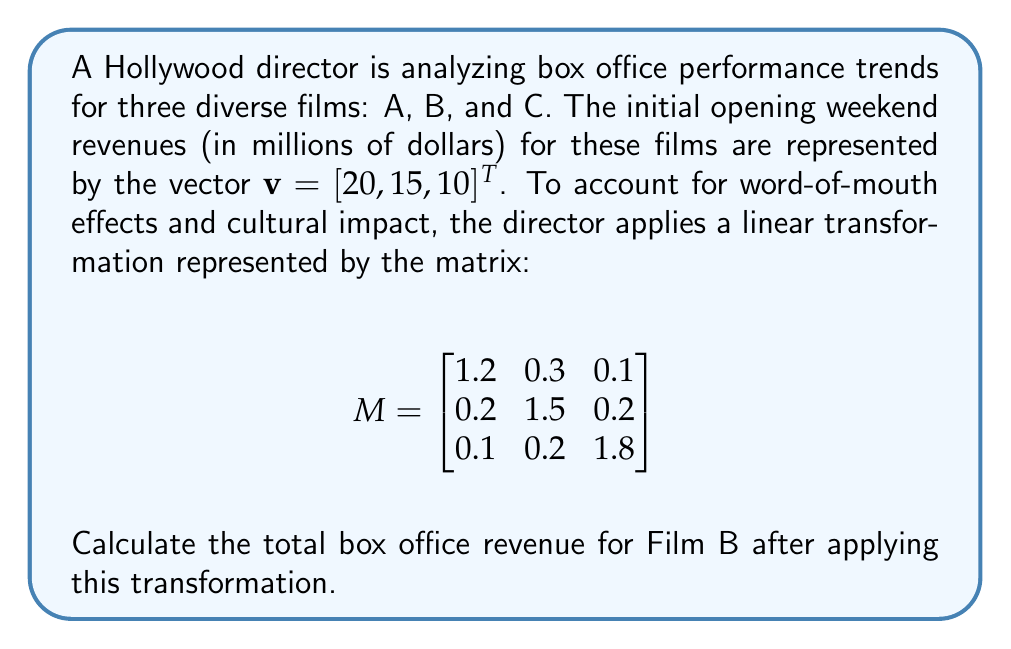Help me with this question. To solve this problem, we need to apply the linear transformation represented by matrix $M$ to the initial revenue vector $\mathbf{v}$. This is done by matrix multiplication:

1) First, let's perform the matrix multiplication $M\mathbf{v}$:

   $$
   \begin{bmatrix}
   1.2 & 0.3 & 0.1 \\
   0.2 & 1.5 & 0.2 \\
   0.1 & 0.2 & 1.8
   \end{bmatrix}
   \begin{bmatrix}
   20 \\
   15 \\
   10
   \end{bmatrix}
   $$

2) Multiply each row of $M$ by $\mathbf{v}$:

   Row 1: $(1.2 \times 20) + (0.3 \times 15) + (0.1 \times 10) = 24 + 4.5 + 1 = 29.5$
   Row 2: $(0.2 \times 20) + (1.5 \times 15) + (0.2 \times 10) = 4 + 22.5 + 2 = 28.5$
   Row 3: $(0.1 \times 20) + (0.2 \times 15) + (1.8 \times 10) = 2 + 3 + 18 = 23$

3) The resulting vector is:

   $$
   \begin{bmatrix}
   29.5 \\
   28.5 \\
   23
   \end{bmatrix}
   $$

4) The question asks for the revenue of Film B, which corresponds to the second element of this vector.

Therefore, the total box office revenue for Film B after applying the transformation is $28.5$ million dollars.
Answer: $28.5$ million dollars 